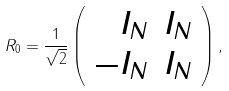Convert formula to latex. <formula><loc_0><loc_0><loc_500><loc_500>R _ { 0 } = \frac { 1 } { \sqrt { 2 } } \left ( \begin{array} { r r } I _ { N } & I _ { N } \\ - I _ { N } & I _ { N } \end{array} \right ) ,</formula> 